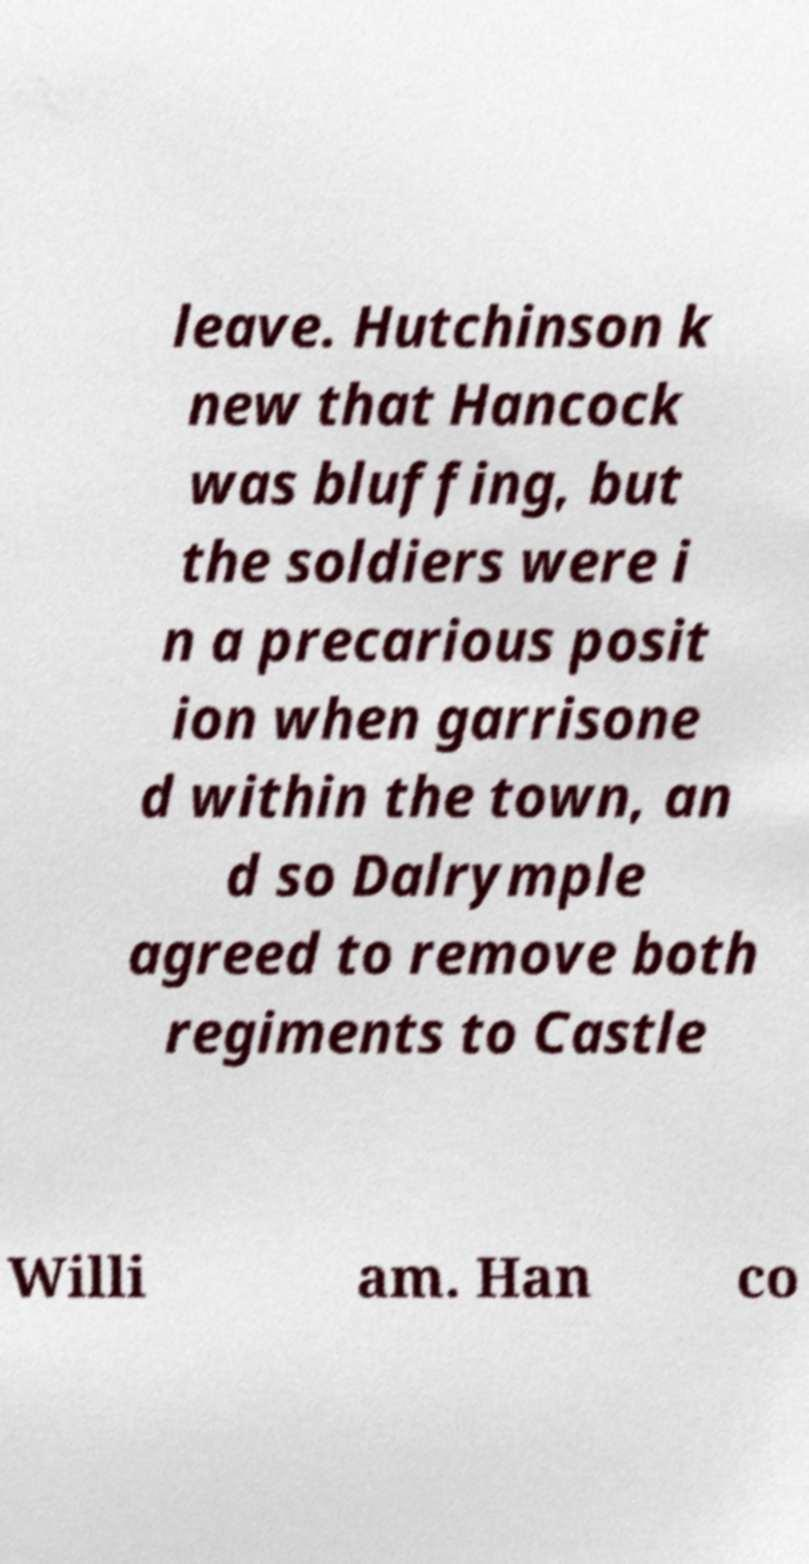Please identify and transcribe the text found in this image. leave. Hutchinson k new that Hancock was bluffing, but the soldiers were i n a precarious posit ion when garrisone d within the town, an d so Dalrymple agreed to remove both regiments to Castle Willi am. Han co 